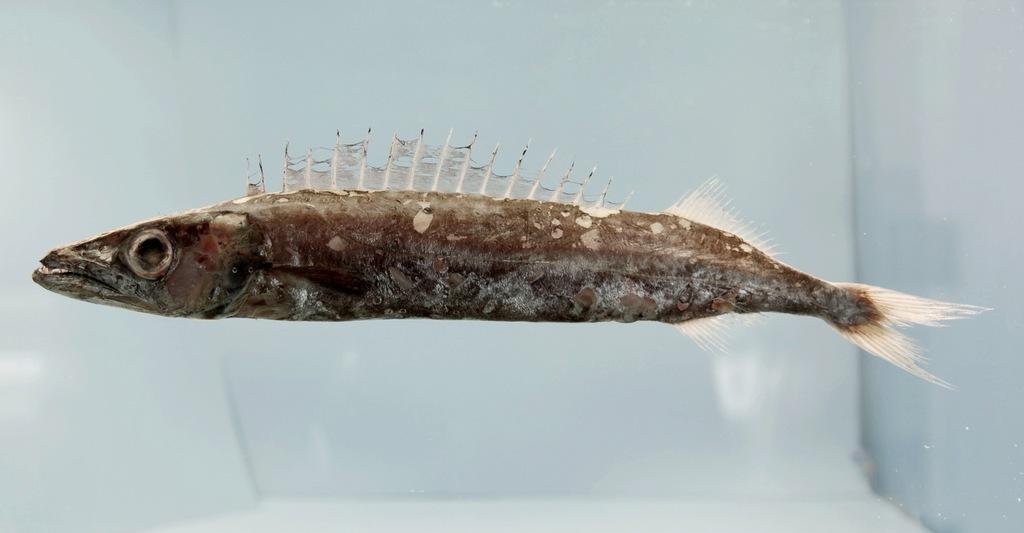What type of animal can be seen in the water in the image? There is a fish in the water in the image. What can be seen in the background of the image? There are walls visible in the background of the image. How many spoons are being used by the fish in the image? There are no spoons present in the image, as it features a fish in the water and spoons are not typically used by fish. 